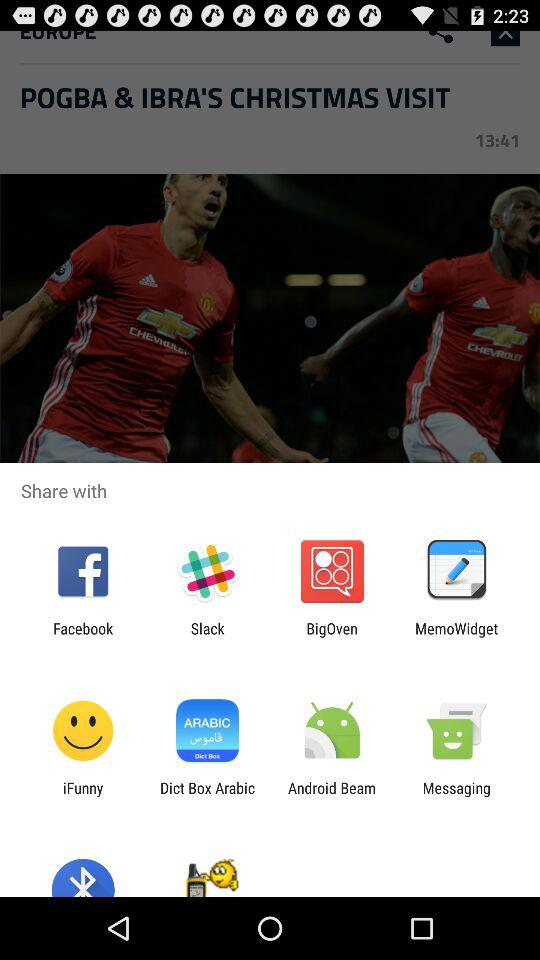Which are the different sharing options? The different sharing options are "Facebook", "Slack", "BigOven", "MemoWidget", "iFunny", "Dict Box Arabic", "Android Beam" and "Messaging". 